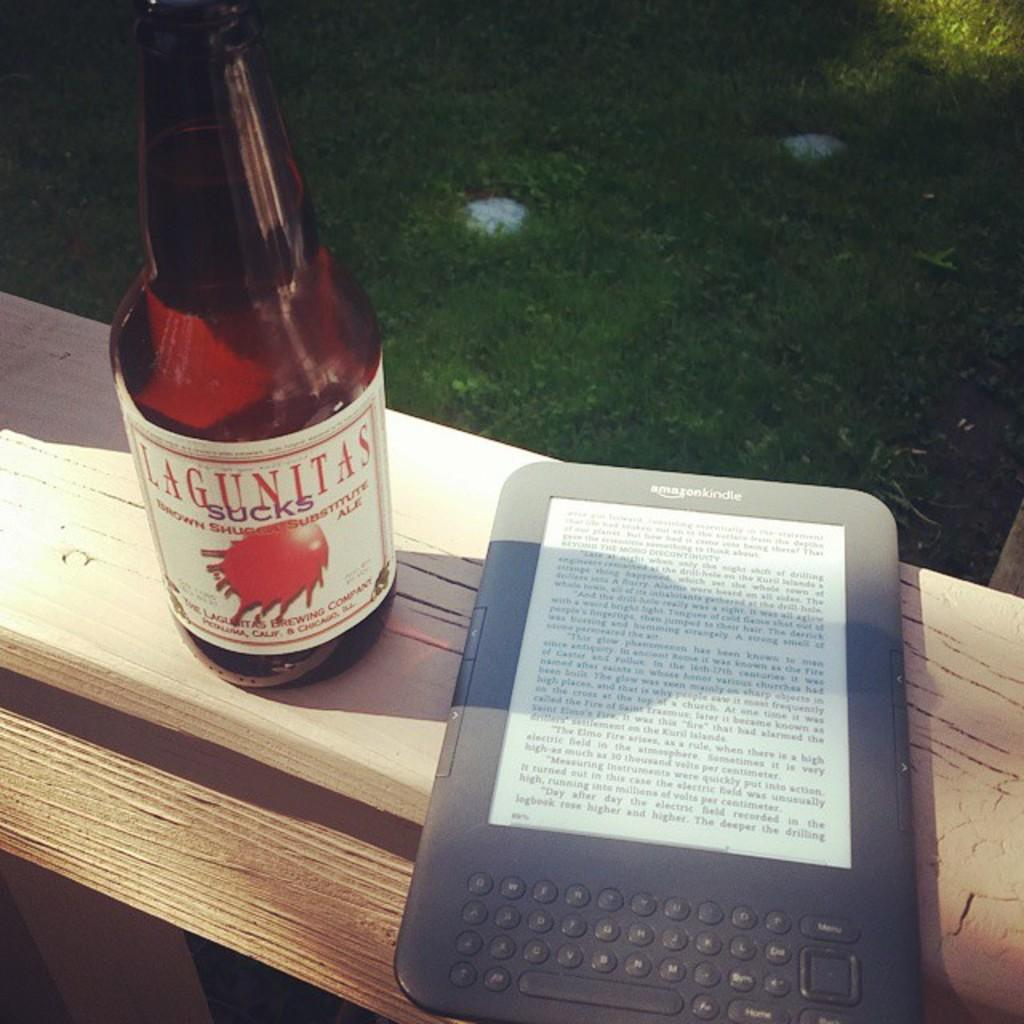<image>
Provide a brief description of the given image. amazon kindle on board next to bottle of lagunitas sucks 